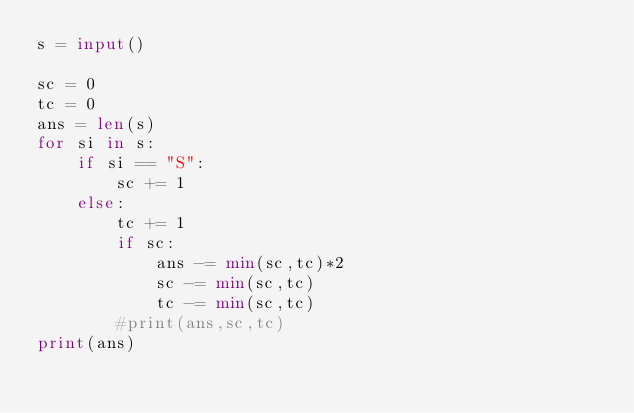Convert code to text. <code><loc_0><loc_0><loc_500><loc_500><_Python_>s = input()

sc = 0
tc = 0
ans = len(s)
for si in s:
    if si == "S":
        sc += 1
    else:
        tc += 1
        if sc:
            ans -= min(sc,tc)*2
            sc -= min(sc,tc)
            tc -= min(sc,tc)
        #print(ans,sc,tc)
print(ans)</code> 